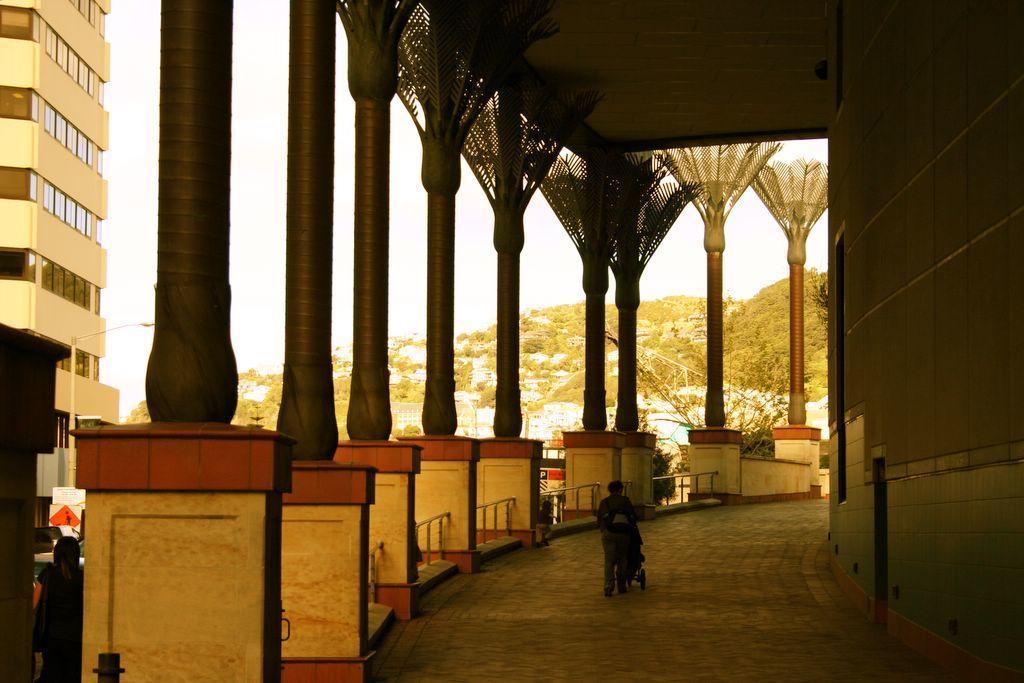Can you describe this image briefly? In this picture I can see a building, there are two persons standing, there are iron grilles, plants, there is a pole and a light, there are houses, trees, hills, and in the background there is sky. 